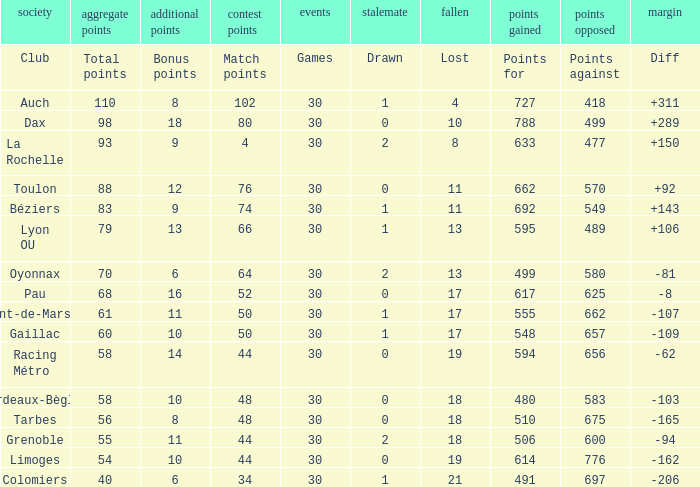What is the number of games for a club that has 34 match points? 30.0. 